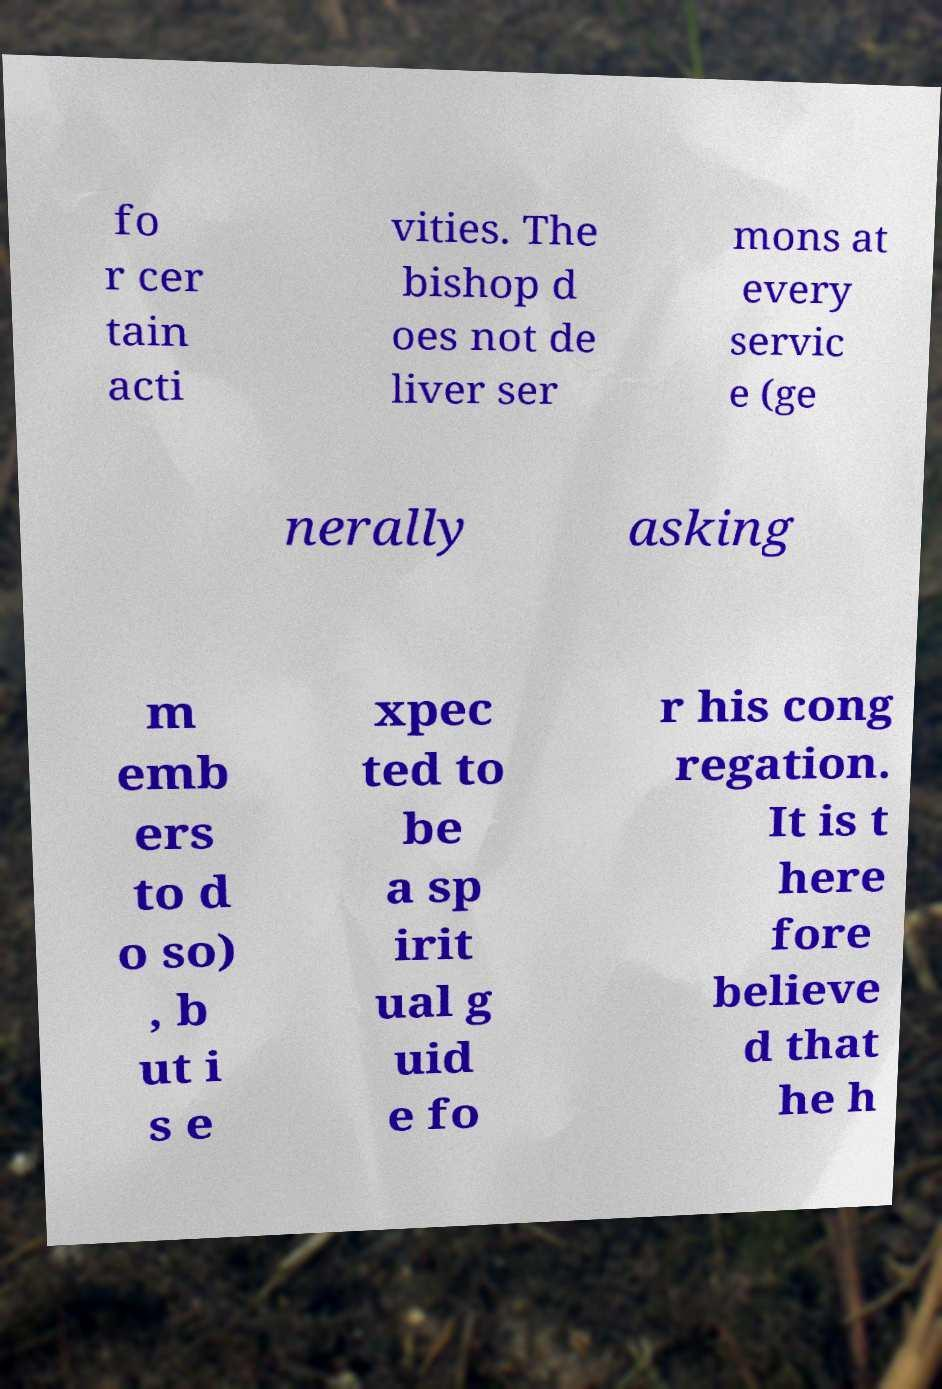Could you extract and type out the text from this image? fo r cer tain acti vities. The bishop d oes not de liver ser mons at every servic e (ge nerally asking m emb ers to d o so) , b ut i s e xpec ted to be a sp irit ual g uid e fo r his cong regation. It is t here fore believe d that he h 